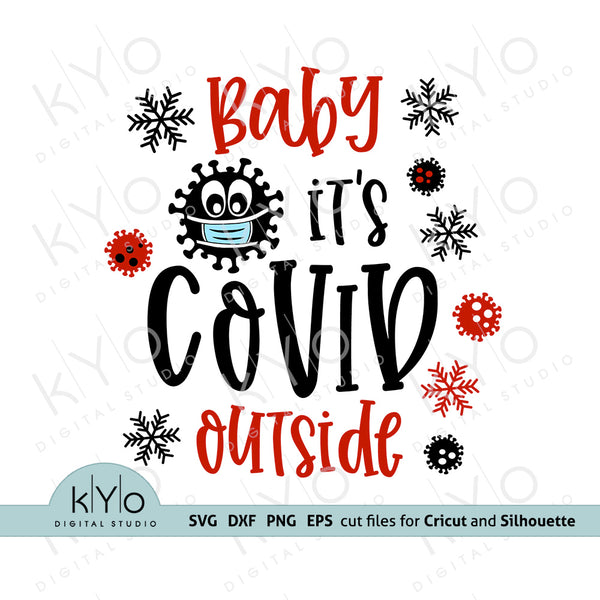Could this kind of imagery contribute to pandemic fatigue, or help in coping with it? Discuss. This imagery could play a role in both contributing to pandemic fatigue and aiding in coping with it. On one hand, constant reminders of the virus, even in a humorous form, could intensify feelings of exhaustion and weariness associated with prolonged periods of health crises. On the other hand, introducing humor and creativity into the dialogue around COVID-19 can be therapeutic. It allows people to express their feelings about the pandemic in a way that is socially shareable and engaging, potentially making the ongoing situation more bearable and less daunting. 